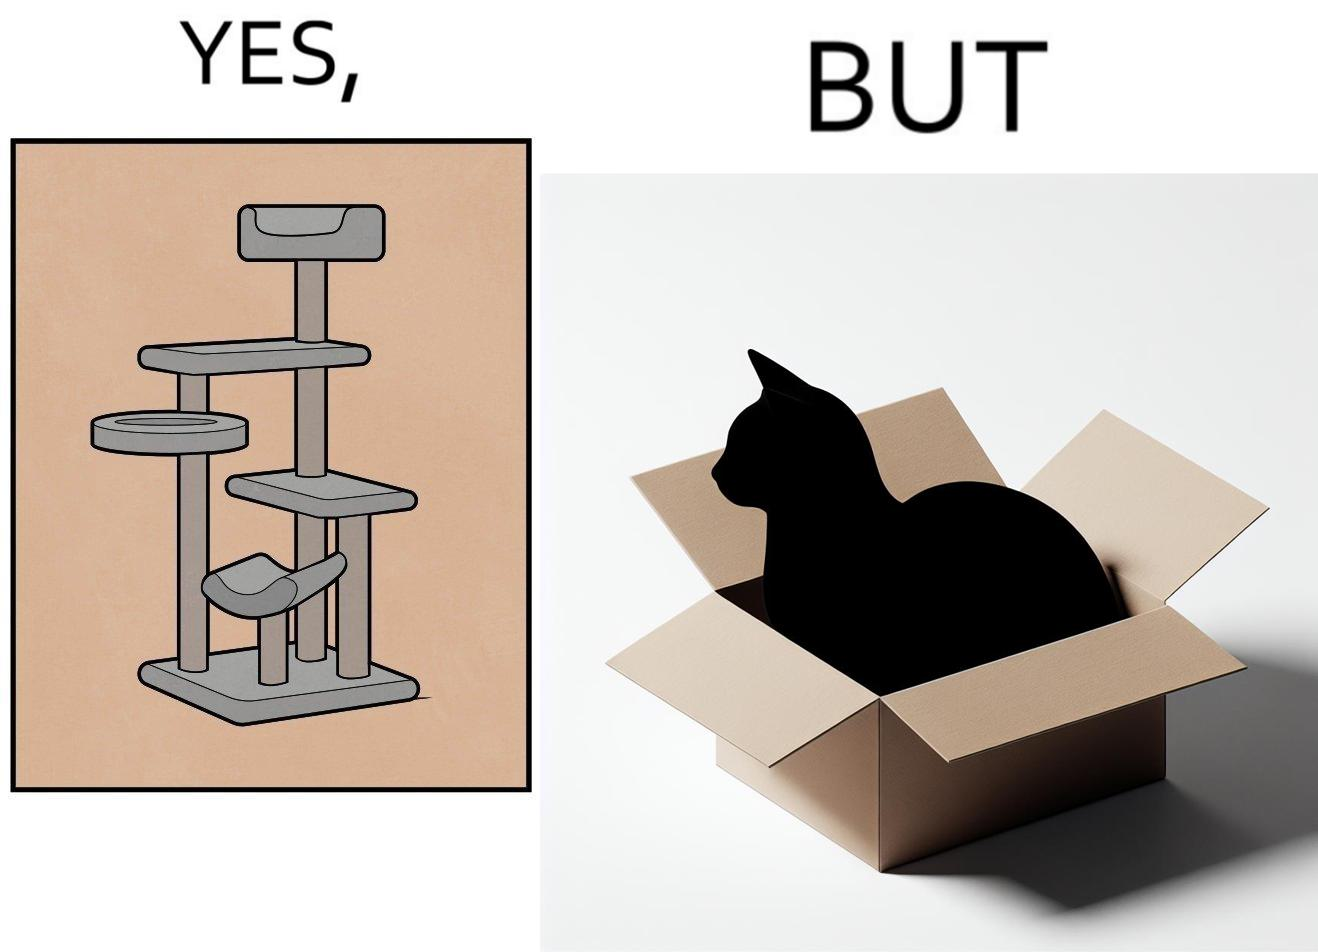Compare the left and right sides of this image. In the left part of the image: It is a cat tree In the right part of the image: It is a cat in a cardboard box 